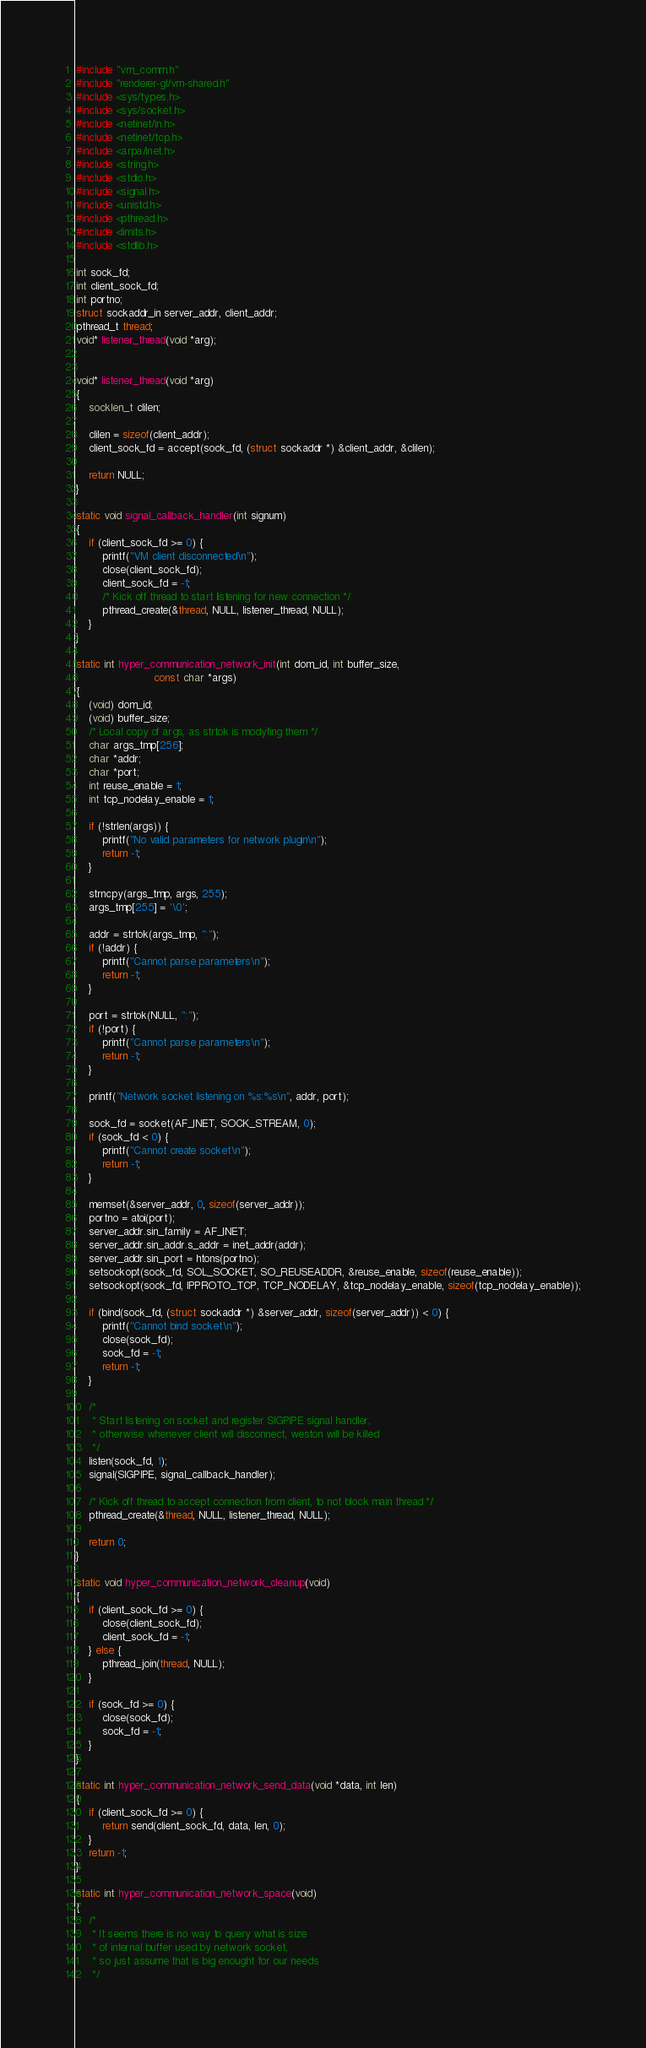<code> <loc_0><loc_0><loc_500><loc_500><_C_>#include "vm_comm.h"
#include "renderer-gl/vm-shared.h"
#include <sys/types.h>
#include <sys/socket.h>
#include <netinet/in.h>
#include <netinet/tcp.h>
#include <arpa/inet.h>
#include <string.h>
#include <stdio.h>
#include <signal.h>
#include <unistd.h>
#include <pthread.h>
#include <limits.h>
#include <stdlib.h>

int sock_fd;
int client_sock_fd;
int portno;
struct sockaddr_in server_addr, client_addr;
pthread_t thread;
void* listener_thread(void *arg);


void* listener_thread(void *arg)
{
	socklen_t clilen;

	clilen = sizeof(client_addr);
	client_sock_fd = accept(sock_fd, (struct sockaddr *) &client_addr, &clilen);

	return NULL;
}

static void signal_callback_handler(int signum)
{
	if (client_sock_fd >= 0) {
		printf("VM client disconnected\n");
		close(client_sock_fd);
		client_sock_fd = -1;
		/* Kick off thread to start listening for new connection */
		pthread_create(&thread, NULL, listener_thread, NULL);
	}
}

static int hyper_communication_network_init(int dom_id, int buffer_size,
					    const char *args)
{
	(void) dom_id;
	(void) buffer_size;
	/* Local copy of args, as strtok is modyfing them */
	char args_tmp[256];
	char *addr;
	char *port;
	int reuse_enable = 1;
	int tcp_nodelay_enable = 1;

	if (!strlen(args)) {
		printf("No valid parameters for network plugin\n");
		return -1;
	}

	strncpy(args_tmp, args, 255);
	args_tmp[255] = '\0';

	addr = strtok(args_tmp, ":");
	if (!addr) {
		printf("Cannot parse parameters\n");
		return -1;
	}

	port = strtok(NULL, ":");
	if (!port) {
		printf("Cannot parse parameters\n");
		return -1;
	}

	printf("Network socket listening on %s:%s\n", addr, port);

	sock_fd = socket(AF_INET, SOCK_STREAM, 0);
	if (sock_fd < 0) {
		printf("Cannot create socket\n");
		return -1;
	}

	memset(&server_addr, 0, sizeof(server_addr));
	portno = atoi(port);
	server_addr.sin_family = AF_INET;
	server_addr.sin_addr.s_addr = inet_addr(addr);
	server_addr.sin_port = htons(portno);
	setsockopt(sock_fd, SOL_SOCKET, SO_REUSEADDR, &reuse_enable, sizeof(reuse_enable));
	setsockopt(sock_fd, IPPROTO_TCP, TCP_NODELAY, &tcp_nodelay_enable, sizeof(tcp_nodelay_enable));

	if (bind(sock_fd, (struct sockaddr *) &server_addr, sizeof(server_addr)) < 0) {
		printf("Cannot bind socket\n");
		close(sock_fd);
		sock_fd = -1;
		return -1;
	}

	/*
	 * Start listening on socket and register SIGPIPE signal handler,
	 * otherwise whenever client will disconnect, weston will be killed
	 */
	listen(sock_fd, 1);
	signal(SIGPIPE, signal_callback_handler);

	/* Kick off thread to accept connection from client, to not block main thread */
	pthread_create(&thread, NULL, listener_thread, NULL);

	return 0;
}

static void hyper_communication_network_cleanup(void)
{
	if (client_sock_fd >= 0) {
		close(client_sock_fd);
		client_sock_fd = -1;
	} else {
		pthread_join(thread, NULL);
	}

	if (sock_fd >= 0) {
		close(sock_fd);
		sock_fd = -1;
	}
}

static int hyper_communication_network_send_data(void *data, int len)
{
	if (client_sock_fd >= 0) {
		return send(client_sock_fd, data, len, 0);
	}
	return -1;
}

static int hyper_communication_network_space(void)
{
	/*
	 * It seems there is no way to query what is size
	 * of internal buffer used by network socket,
	 * so just assume that is big enought for our needs
	 */</code> 